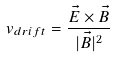Convert formula to latex. <formula><loc_0><loc_0><loc_500><loc_500>v _ { d r i f t } = \frac { \vec { E } \times \vec { B } } { | \vec { B } | ^ { 2 } }</formula> 